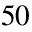<formula> <loc_0><loc_0><loc_500><loc_500>5 0</formula> 